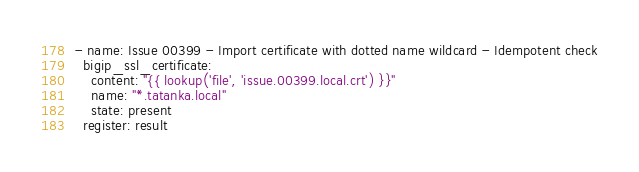Convert code to text. <code><loc_0><loc_0><loc_500><loc_500><_YAML_>
- name: Issue 00399 - Import certificate with dotted name wildcard - Idempotent check
  bigip_ssl_certificate:
    content: "{{ lookup('file', 'issue.00399.local.crt') }}"
    name: "*.tatanka.local"
    state: present
  register: result
</code> 